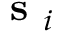<formula> <loc_0><loc_0><loc_500><loc_500>s _ { i }</formula> 